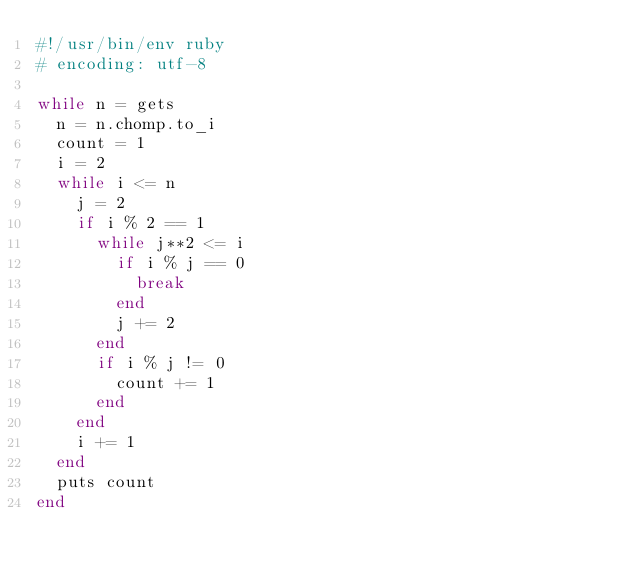Convert code to text. <code><loc_0><loc_0><loc_500><loc_500><_Ruby_>#!/usr/bin/env ruby
# encoding: utf-8

while n = gets
	n = n.chomp.to_i
	count = 1
	i = 2
	while i <= n
		j = 2
		if i % 2 == 1
			while j**2 <= i
				if i % j == 0
					break
				end
				j += 2
			end
			if i % j != 0
				count += 1
			end
		end
		i += 1 
	end
	puts count
end</code> 